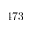<formula> <loc_0><loc_0><loc_500><loc_500>4 7 3</formula> 